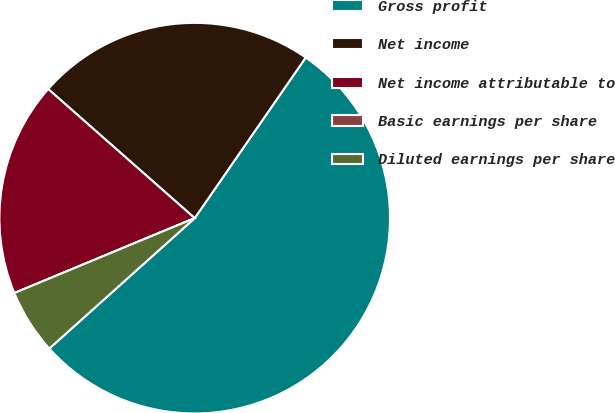Convert chart. <chart><loc_0><loc_0><loc_500><loc_500><pie_chart><fcel>Gross profit<fcel>Net income<fcel>Net income attributable to<fcel>Basic earnings per share<fcel>Diluted earnings per share<nl><fcel>53.74%<fcel>23.13%<fcel>17.76%<fcel>0.0%<fcel>5.37%<nl></chart> 